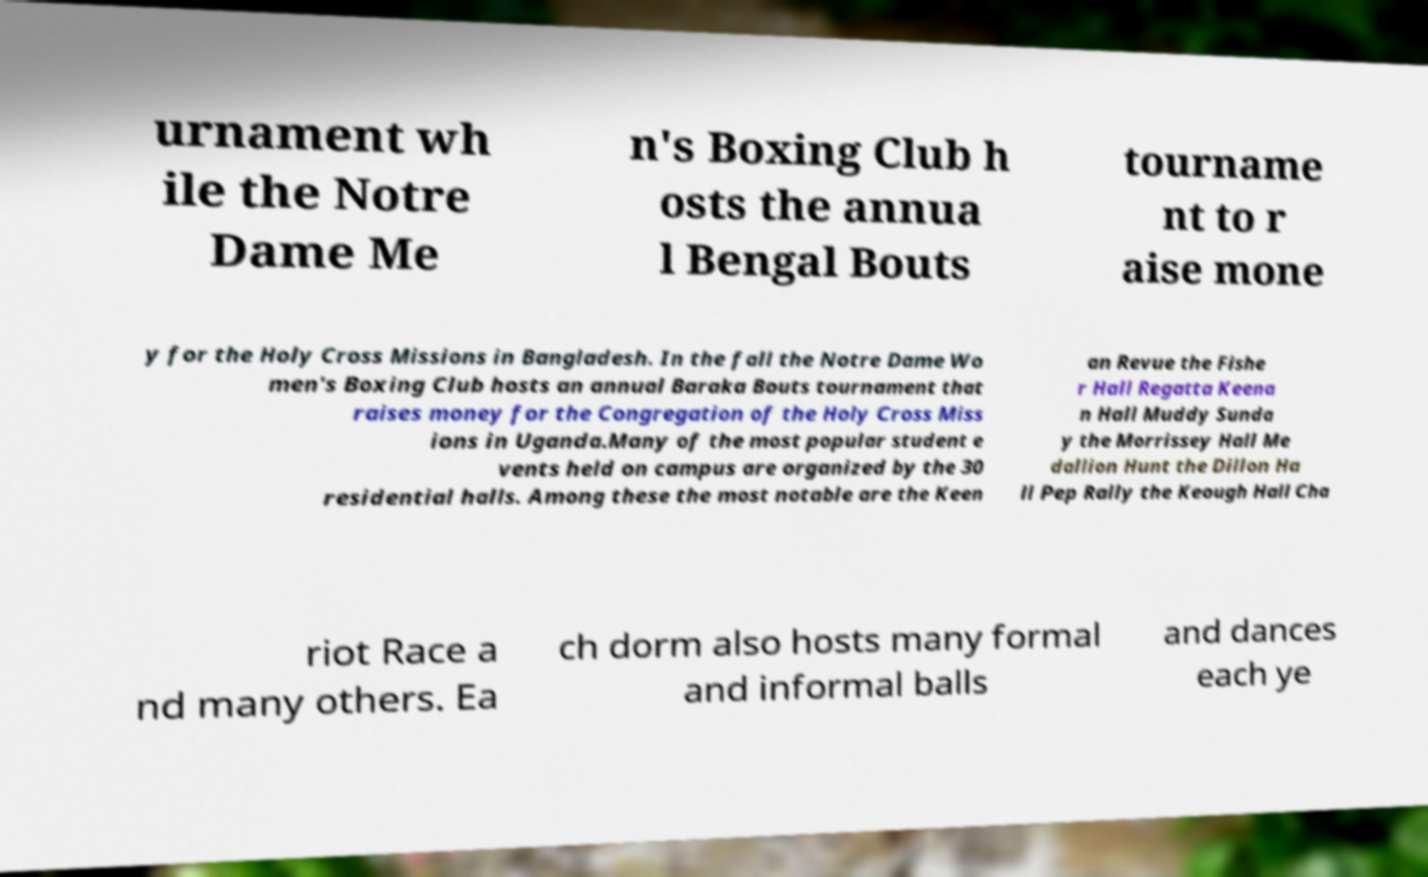There's text embedded in this image that I need extracted. Can you transcribe it verbatim? urnament wh ile the Notre Dame Me n's Boxing Club h osts the annua l Bengal Bouts tourname nt to r aise mone y for the Holy Cross Missions in Bangladesh. In the fall the Notre Dame Wo men's Boxing Club hosts an annual Baraka Bouts tournament that raises money for the Congregation of the Holy Cross Miss ions in Uganda.Many of the most popular student e vents held on campus are organized by the 30 residential halls. Among these the most notable are the Keen an Revue the Fishe r Hall Regatta Keena n Hall Muddy Sunda y the Morrissey Hall Me dallion Hunt the Dillon Ha ll Pep Rally the Keough Hall Cha riot Race a nd many others. Ea ch dorm also hosts many formal and informal balls and dances each ye 